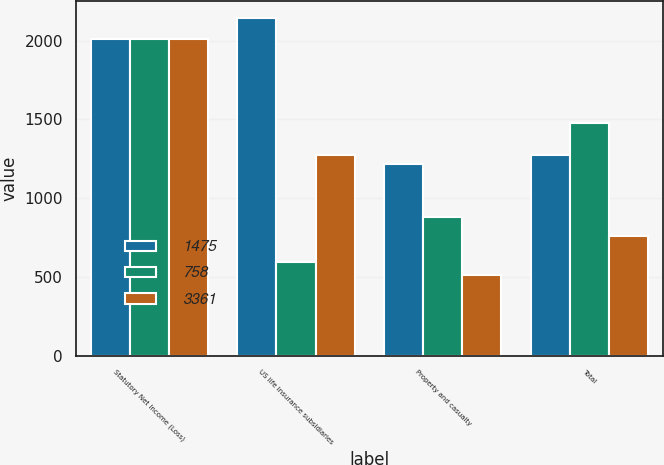Convert chart. <chart><loc_0><loc_0><loc_500><loc_500><stacked_bar_chart><ecel><fcel>Statutory Net Income (Loss)<fcel>US life insurance subsidiaries<fcel>Property and casualty<fcel>Total<nl><fcel>1475<fcel>2013<fcel>2144<fcel>1217<fcel>1272<nl><fcel>758<fcel>2012<fcel>592<fcel>883<fcel>1475<nl><fcel>3361<fcel>2011<fcel>1272<fcel>514<fcel>758<nl></chart> 